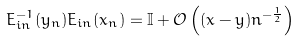<formula> <loc_0><loc_0><loc_500><loc_500>E _ { i n } ^ { - 1 } ( y _ { n } ) E _ { i n } ( x _ { n } ) = \mathbb { I } + \mathcal { O } \left ( ( x - y ) n ^ { - \frac { 1 } { 2 } } \right )</formula> 